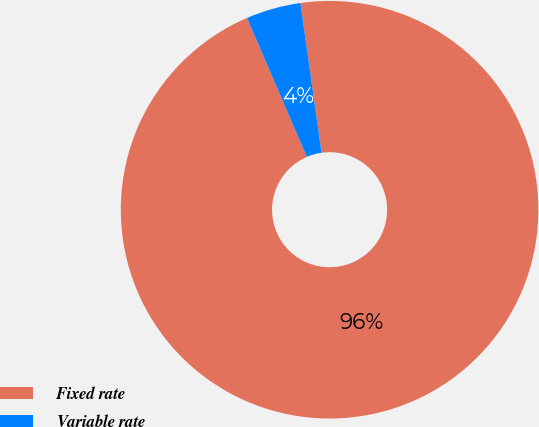Convert chart. <chart><loc_0><loc_0><loc_500><loc_500><pie_chart><fcel>Fixed rate<fcel>Variable rate<nl><fcel>95.76%<fcel>4.24%<nl></chart> 